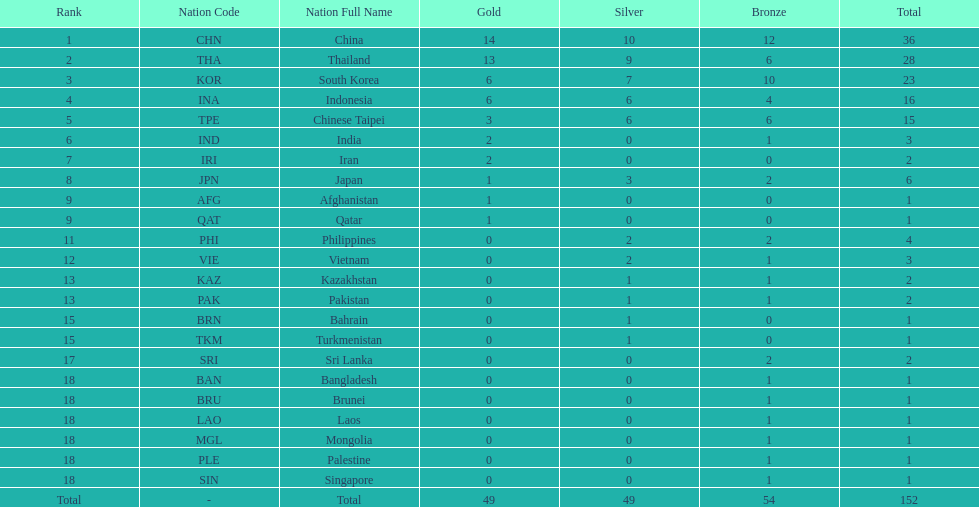What was the number of medals earned by indonesia (ina) ? 16. 